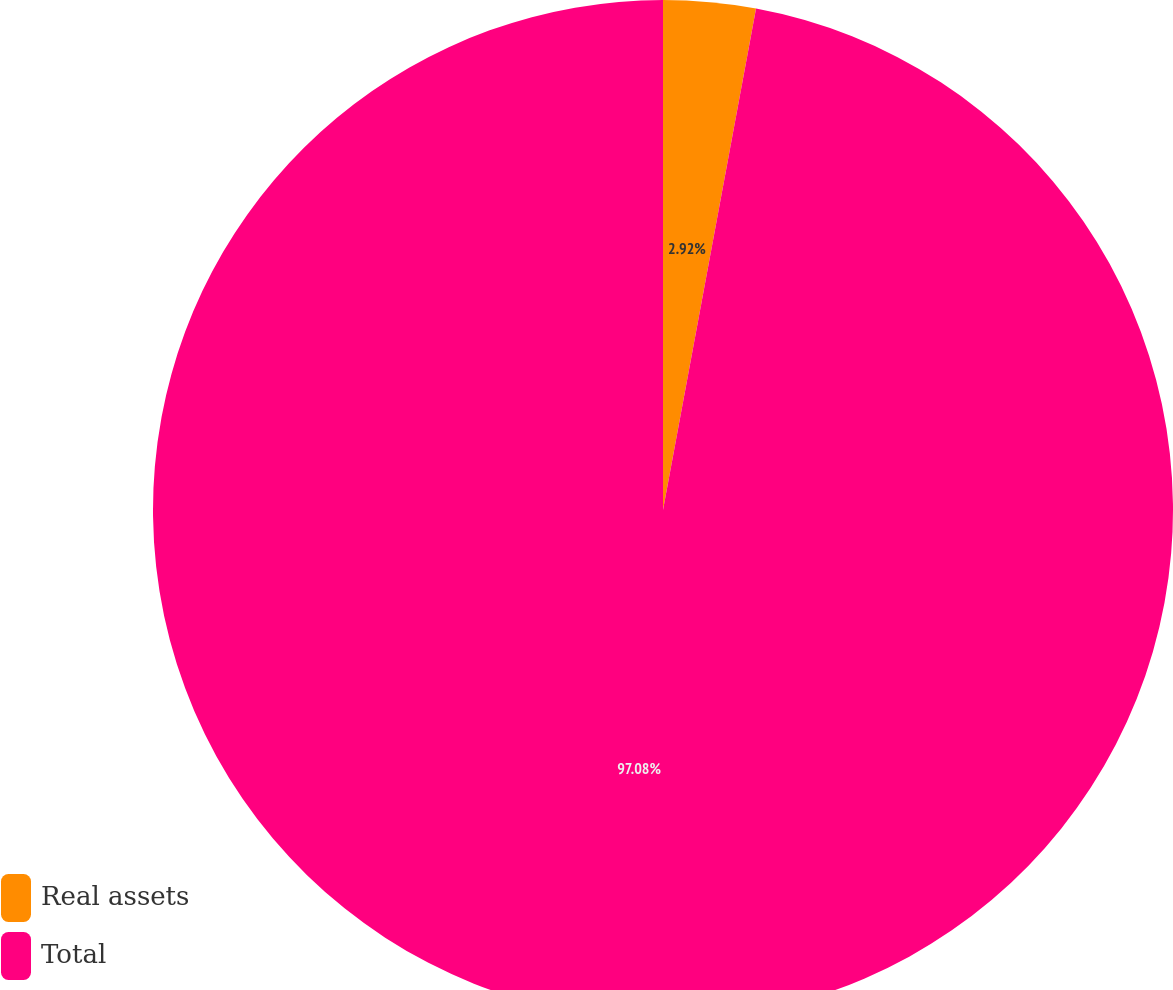Convert chart. <chart><loc_0><loc_0><loc_500><loc_500><pie_chart><fcel>Real assets<fcel>Total<nl><fcel>2.92%<fcel>97.08%<nl></chart> 